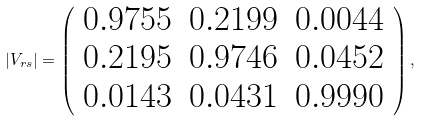<formula> <loc_0><loc_0><loc_500><loc_500>| V _ { r s } | = \left ( \begin{array} { c c c } { 0 . 9 7 5 5 } & { 0 . 2 1 9 9 } & { 0 . 0 0 4 4 } \\ { 0 . 2 1 9 5 } & { 0 . 9 7 4 6 } & { 0 . 0 4 5 2 } \\ { 0 . 0 1 4 3 } & { 0 . 0 4 3 1 } & { 0 . 9 9 9 0 } \end{array} \right ) ,</formula> 